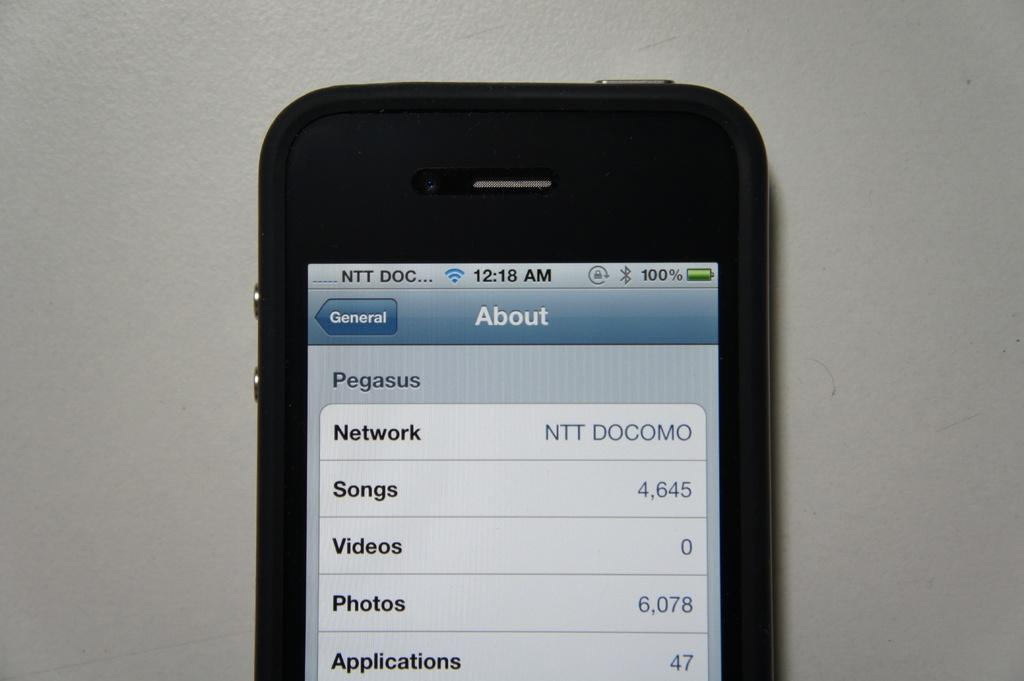<image>
Provide a brief description of the given image. A cell phone displays an About screen for Pegasus. 